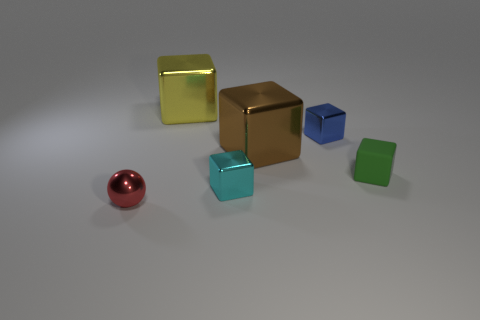Add 4 cyan metallic things. How many objects exist? 10 Subtract all large cubes. How many cubes are left? 3 Subtract all brown cubes. How many cubes are left? 4 Subtract 4 blocks. How many blocks are left? 1 Subtract all purple cubes. Subtract all blue spheres. How many cubes are left? 5 Subtract all cubes. How many objects are left? 1 Subtract all small red objects. Subtract all matte cubes. How many objects are left? 4 Add 1 small red objects. How many small red objects are left? 2 Add 6 tiny purple shiny cylinders. How many tiny purple shiny cylinders exist? 6 Subtract 0 yellow spheres. How many objects are left? 6 